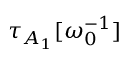Convert formula to latex. <formula><loc_0><loc_0><loc_500><loc_500>\tau _ { A _ { 1 } } [ \omega _ { 0 } ^ { - 1 } ]</formula> 